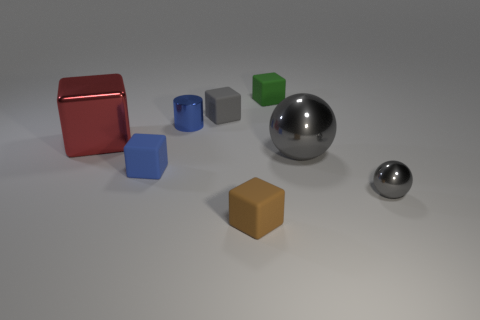Subtract all brown blocks. How many blocks are left? 4 Subtract all tiny brown cubes. How many cubes are left? 4 Subtract all blue cubes. Subtract all green spheres. How many cubes are left? 4 Add 1 big brown blocks. How many objects exist? 9 Subtract all balls. How many objects are left? 6 Add 8 small blue metallic cylinders. How many small blue metallic cylinders are left? 9 Add 6 green matte things. How many green matte things exist? 7 Subtract 1 brown cubes. How many objects are left? 7 Subtract all tiny brown rubber cubes. Subtract all blue cubes. How many objects are left? 6 